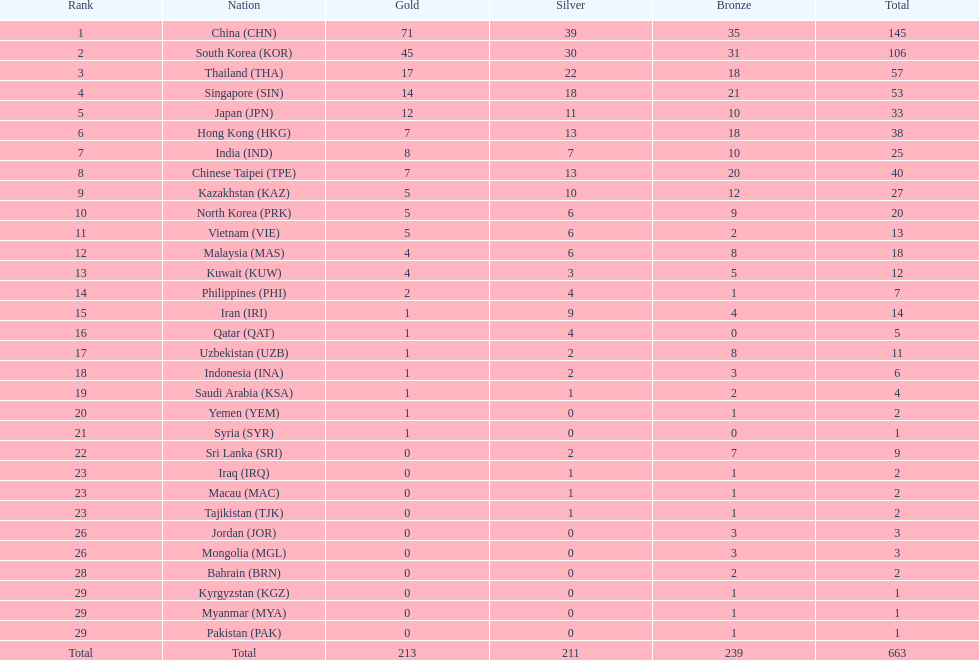Which country has a higher gold medal count, kuwait or india? India (IND). 